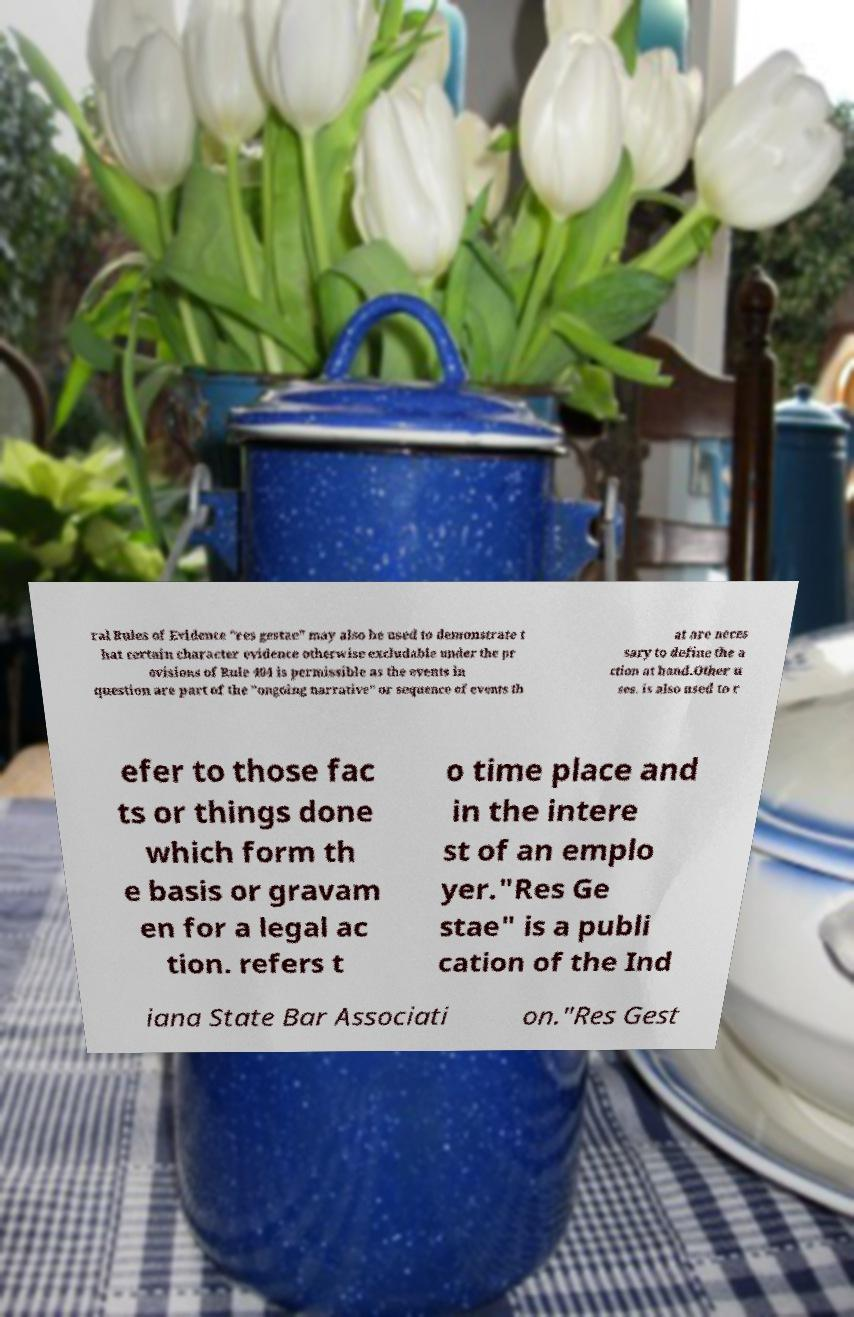What messages or text are displayed in this image? I need them in a readable, typed format. ral Rules of Evidence "res gestae" may also be used to demonstrate t hat certain character evidence otherwise excludable under the pr ovisions of Rule 404 is permissible as the events in question are part of the "ongoing narrative" or sequence of events th at are neces sary to define the a ction at hand.Other u ses. is also used to r efer to those fac ts or things done which form th e basis or gravam en for a legal ac tion. refers t o time place and in the intere st of an emplo yer."Res Ge stae" is a publi cation of the Ind iana State Bar Associati on."Res Gest 